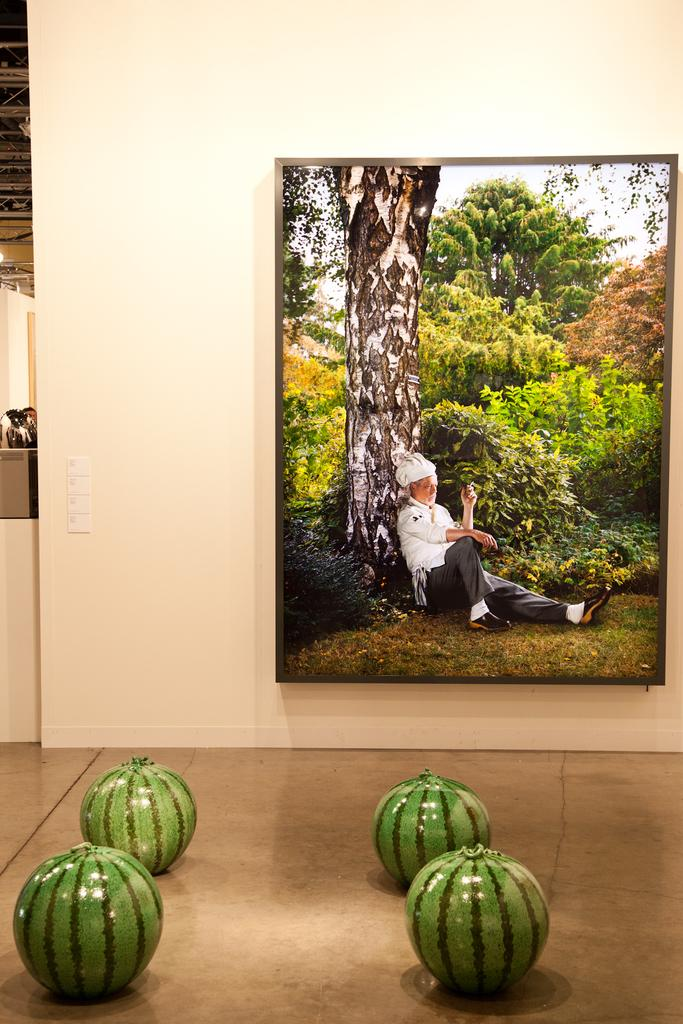What is hanging on the wall in the image? There is a frame on the wall in the image. How many objects are on the floor in the image? There are four objects on the floor in the image. What type of brass instrument can be seen in the image? There is no brass instrument present in the image. What is the minister doing in the image? There is no minister present in the image. What sound can be heard from the whistle in the image? There is no whistle present in the image. 